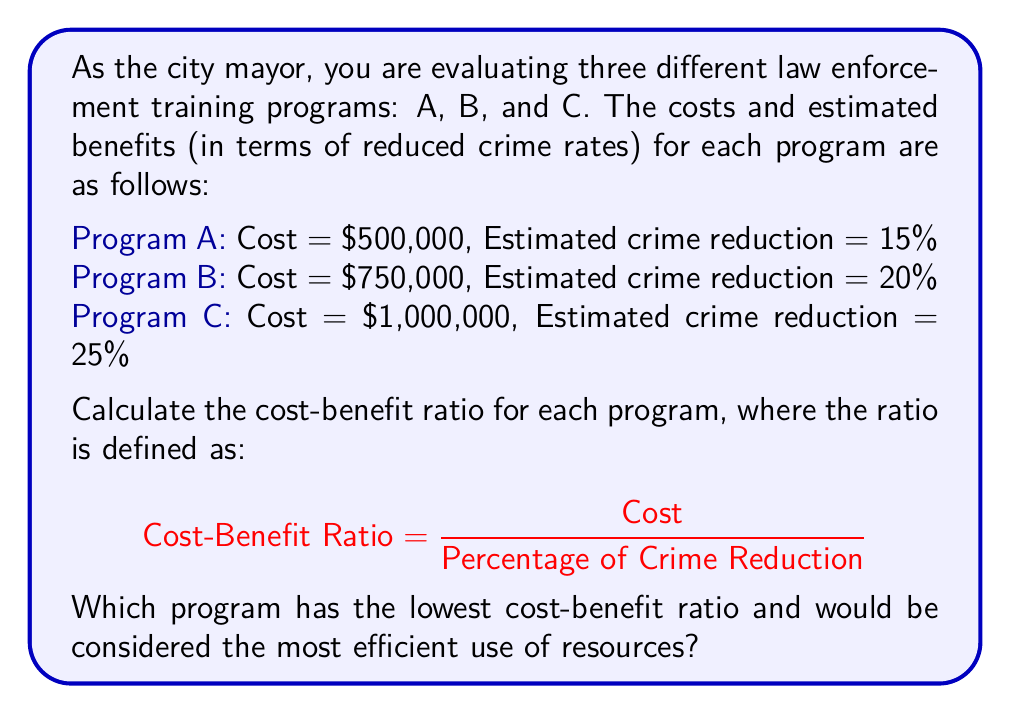Provide a solution to this math problem. To solve this problem, we need to calculate the cost-benefit ratio for each program using the given formula:

$$ \text{Cost-Benefit Ratio} = \frac{\text{Cost}}{\text{Percentage of Crime Reduction}} $$

For Program A:
$$ \text{Ratio}_A = \frac{\$500,000}{15\%} = \frac{500,000}{0.15} = \$3,333,333.33 \text{ per percentage point} $$

For Program B:
$$ \text{Ratio}_B = \frac{\$750,000}{20\%} = \frac{750,000}{0.20} = \$3,750,000 \text{ per percentage point} $$

For Program C:
$$ \text{Ratio}_C = \frac{\$1,000,000}{25\%} = \frac{1,000,000}{0.25} = \$4,000,000 \text{ per percentage point} $$

The lower the ratio, the more efficient the program is in terms of cost per percentage point of crime reduction. Comparing the ratios:

$$ \text{Ratio}_A < \text{Ratio}_B < \text{Ratio}_C $$

Therefore, Program A has the lowest cost-benefit ratio and would be considered the most efficient use of resources.
Answer: Program A has the lowest cost-benefit ratio at $3,333,333.33 per percentage point of crime reduction, making it the most efficient use of resources. 